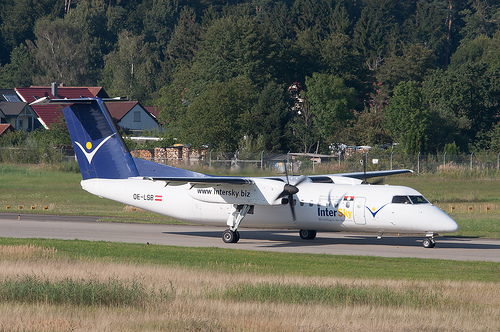Please provide the bounding box coordinate of the region this sentence describes: green leaves in brown trees. The bounding box coordinates for the region describing 'green leaves in brown trees' are [0.48, 0.21, 0.59, 0.31]. This likely identifies a segment of the image featuring foliage within a wooded area. 